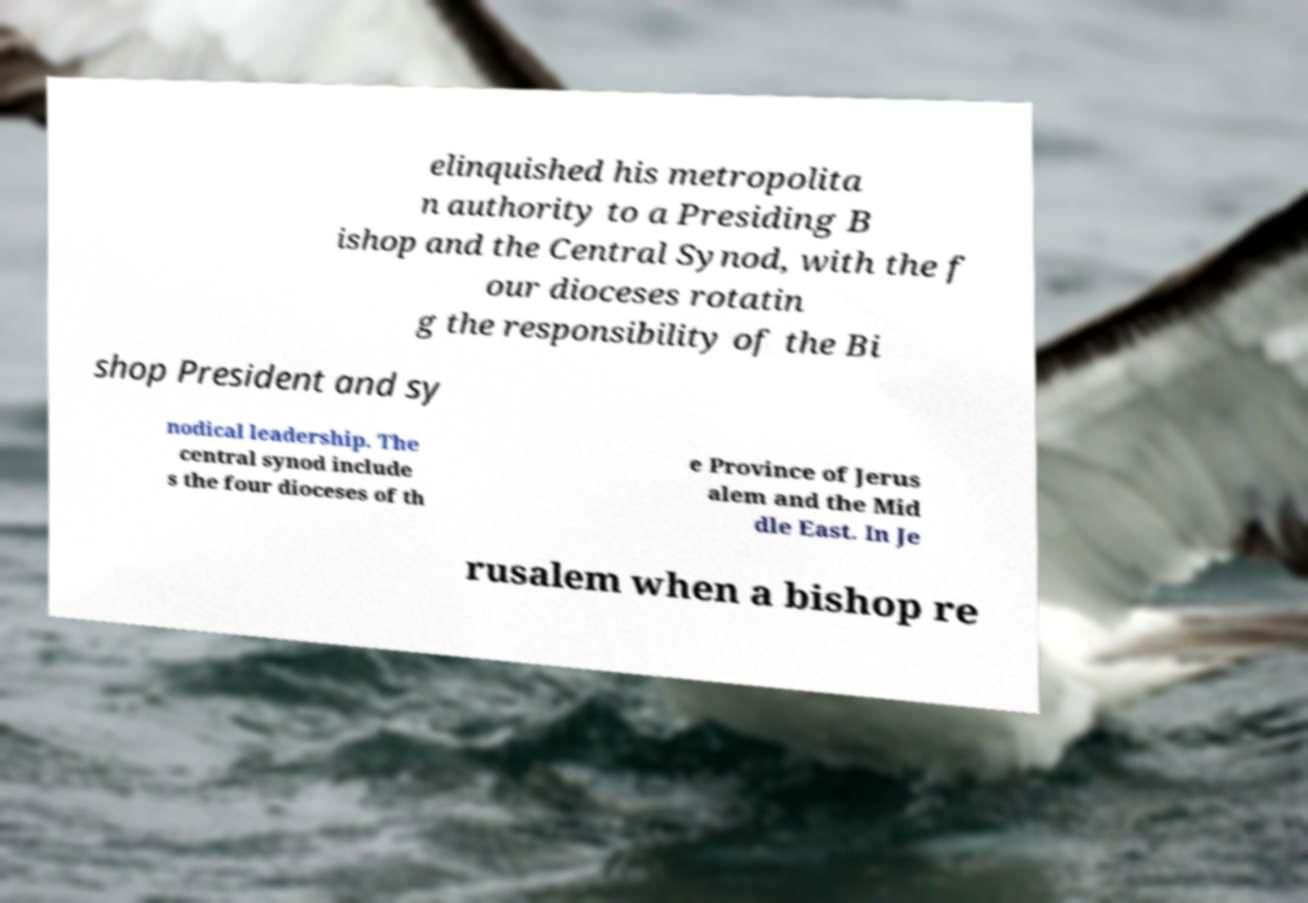For documentation purposes, I need the text within this image transcribed. Could you provide that? elinquished his metropolita n authority to a Presiding B ishop and the Central Synod, with the f our dioceses rotatin g the responsibility of the Bi shop President and sy nodical leadership. The central synod include s the four dioceses of th e Province of Jerus alem and the Mid dle East. In Je rusalem when a bishop re 